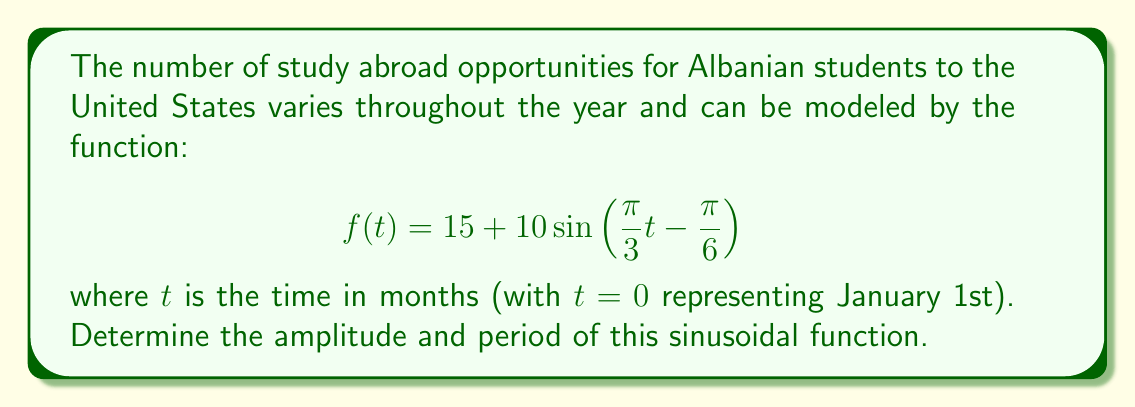Can you answer this question? To find the amplitude and period of this sinusoidal function, we need to analyze its components:

1. Amplitude:
   The general form of a sine function is $A\sin(B(t-C)) + D$, where $A$ is the amplitude.
   In our function, $f(t) = 15 + 10\sin\left(\frac{\pi}{3}t - \frac{\pi}{6}\right)$
   We can see that $A = 10$, so the amplitude is 10.

2. Period:
   For a sine function in the form $\sin(Bt)$, the period is given by $\frac{2\pi}{|B|}$
   In our function, $B = \frac{\pi}{3}$
   
   Period $= \frac{2\pi}{|\frac{\pi}{3}|} = \frac{2\pi}{\frac{\pi}{3}} = 2 \cdot 3 = 6$

   Therefore, the period is 6 months.

This means that the number of study abroad opportunities fluctuates by 10 above and below the average of 15, and the pattern repeats every 6 months.
Answer: Amplitude: 10, Period: 6 months 